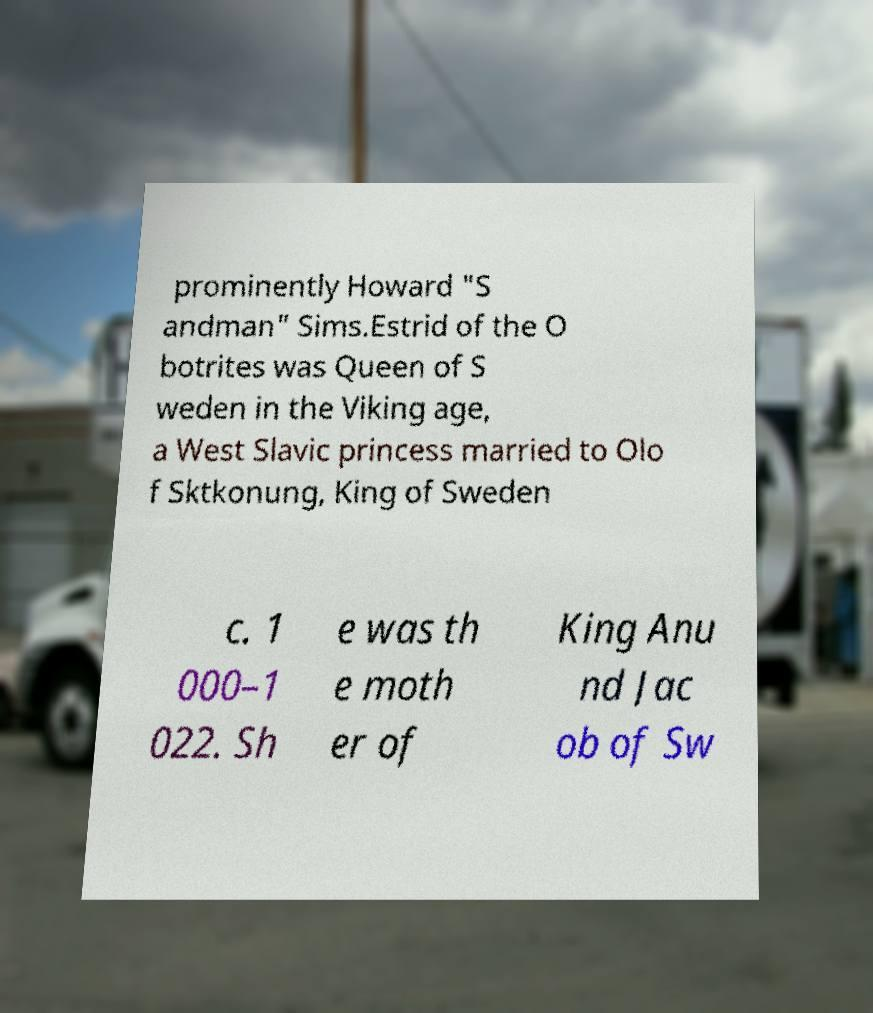Could you extract and type out the text from this image? prominently Howard "S andman" Sims.Estrid of the O botrites was Queen of S weden in the Viking age, a West Slavic princess married to Olo f Sktkonung, King of Sweden c. 1 000–1 022. Sh e was th e moth er of King Anu nd Jac ob of Sw 